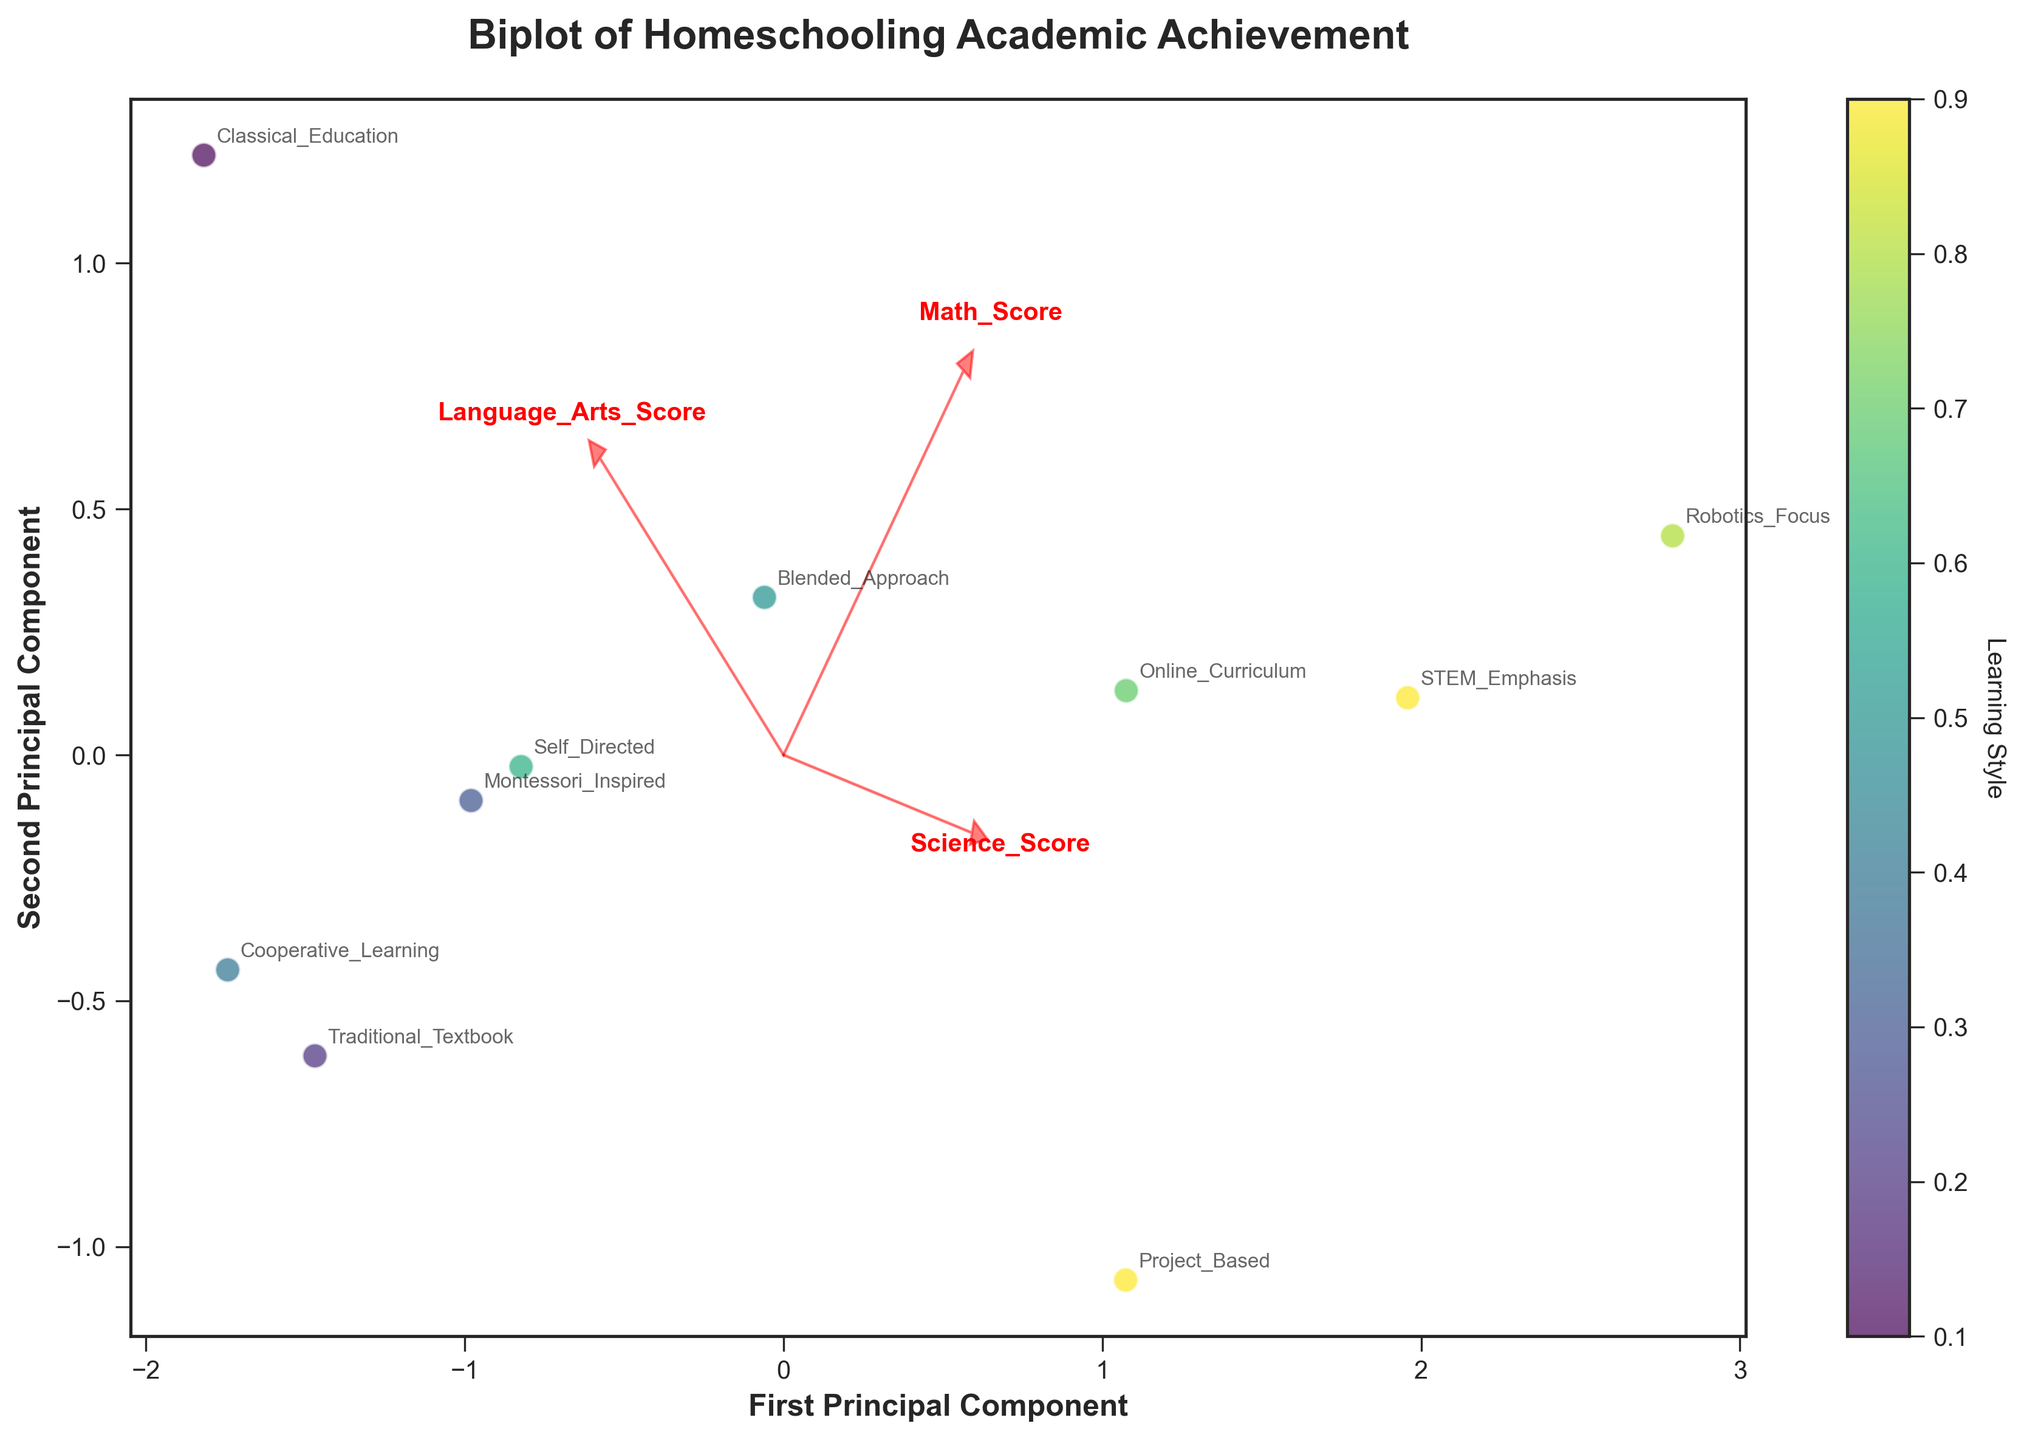What is the title of the biplot? The title of a plot is usually positioned near the top of the figure, providing an overall description of what the plot is about. In this case, the title is "Biplot of Homeschooling Academic Achievement".
Answer: Biplot of Homeschooling Academic Achievement Which subject has the highest Math_Score? Look at the annotations for each subject and their corresponding positions on the x-axis (First Principal Component) and y-axis (Second Principal Component). The subject "Robotics_Focus" is placed furthest along the direction of the Math_Score vector.
Answer: Robotics_Focus How many principal components are displayed on the axes? Principal components are indicated by the labels on the x-axis and y-axis. In this biplot, there are two principal components, indicated by the labels "First Principal Component" and "Second Principal Component".
Answer: 2 Which learning style color corresponds to the highest average score? Check the color legend for different Learning Style values, and then compare the positions of the points. The learning style with value 0.9 (STEM_Emphasis and Project_Based) achieves the highest average scores across subjects.
Answer: 0.9 Which score vector is closest to the robotics-focused learning style? Look for the "Robotics_Focus" annotation and compare its position relative to the vectors. The score vector closest to the "Robotics_Focus" annotation is the one for Math_Score.
Answer: Math_Score What scores do Traditional_Textbook students have in Science and Language Arts compared to Blended_Approach students? For "Traditional_Textbook", the vector positions are near 82 for Science and 88 for Language Arts. For "Blended_Approach", the vector positions are near 91 for both Science and Language Arts. Thus, "Blended_Approach" students have higher scores.
Answer: Blended_Approach students have higher scores What is the relationship between Science_Score and STEM_Emphasis? Compare the direction of the Science_Score vector and the position of the "STEM_Emphasis". The "STEM_Emphasis" is aligned closely with the Science_Score vector, indicating a high positive relationship.
Answer: High positive relationship Is there a positive or negative correlation between Math_Score and Language_Arts_Score? Check the angles between the vectors for Math_Score and Language_Arts_Score. If the vectors are close to each other, the correlation is positive. If they are in opposite directions, it is negative. They are relatively close, indicating a positive correlation.
Answer: Positive correlation Which subject has the most balanced performance across all scores? Look at scores that are near the center of the plot (0,0 for PC1 and PC2), indicating balanced performance. "Blended_Approach" appears close to the center, meaning balanced scores in all subjects.
Answer: Blended_Approach 